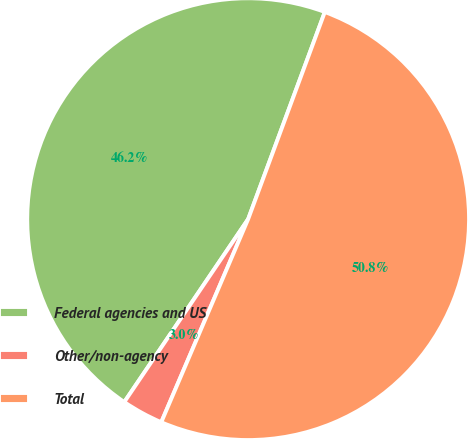Convert chart. <chart><loc_0><loc_0><loc_500><loc_500><pie_chart><fcel>Federal agencies and US<fcel>Other/non-agency<fcel>Total<nl><fcel>46.17%<fcel>3.04%<fcel>50.79%<nl></chart> 